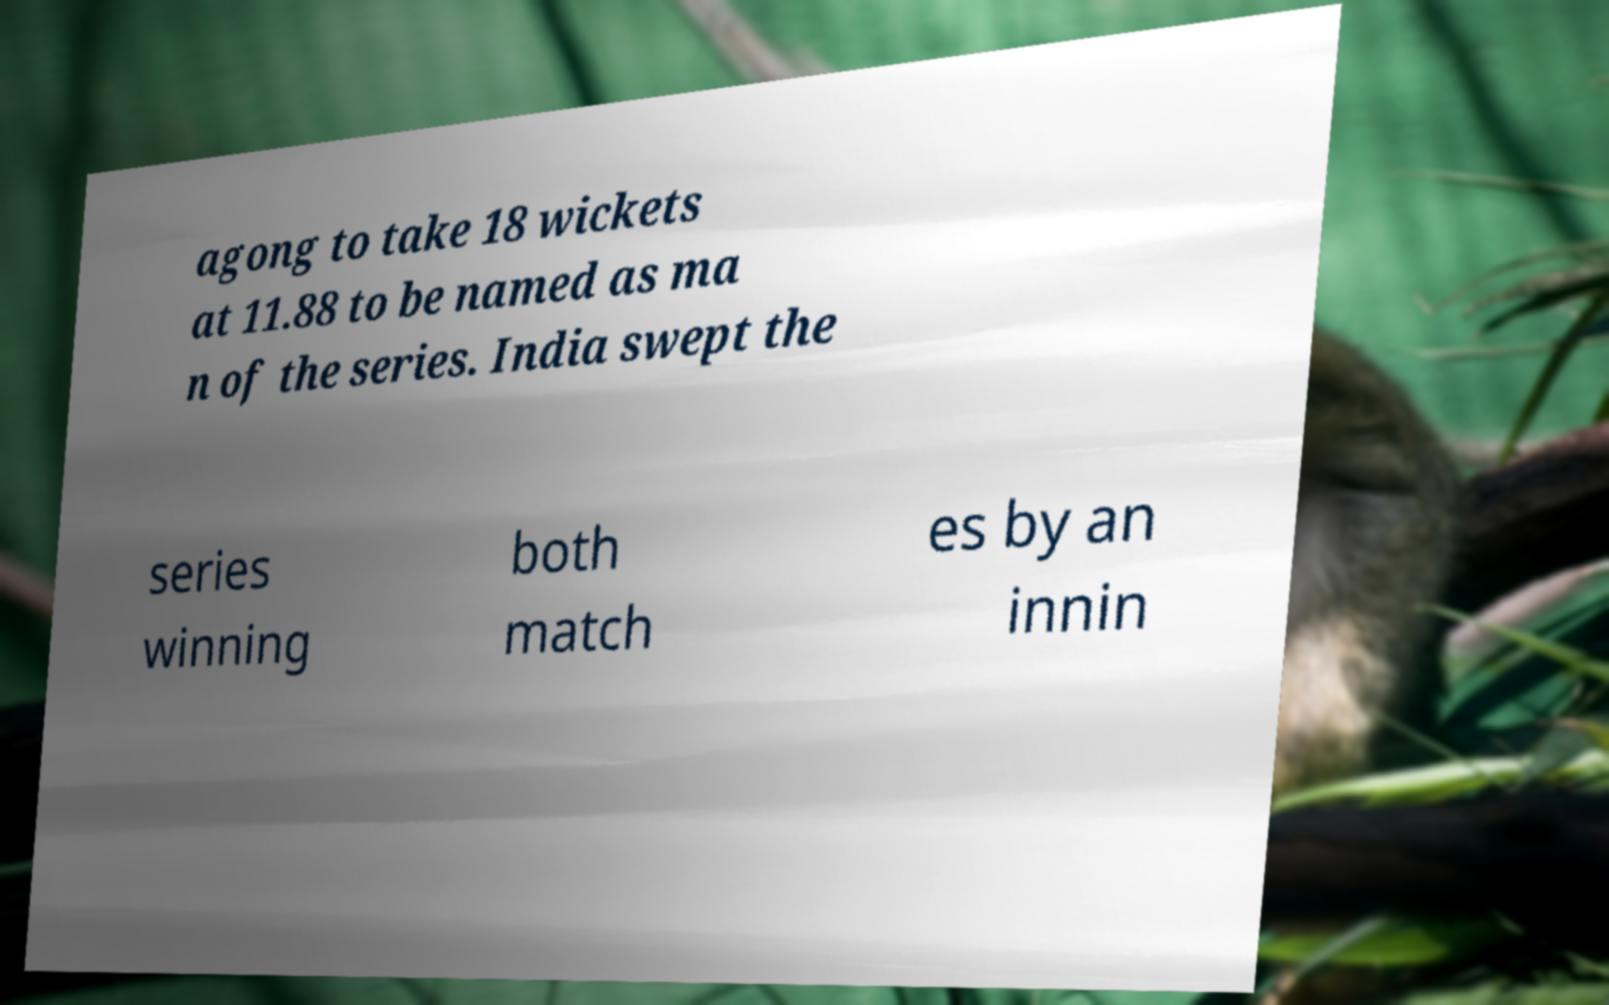There's text embedded in this image that I need extracted. Can you transcribe it verbatim? agong to take 18 wickets at 11.88 to be named as ma n of the series. India swept the series winning both match es by an innin 